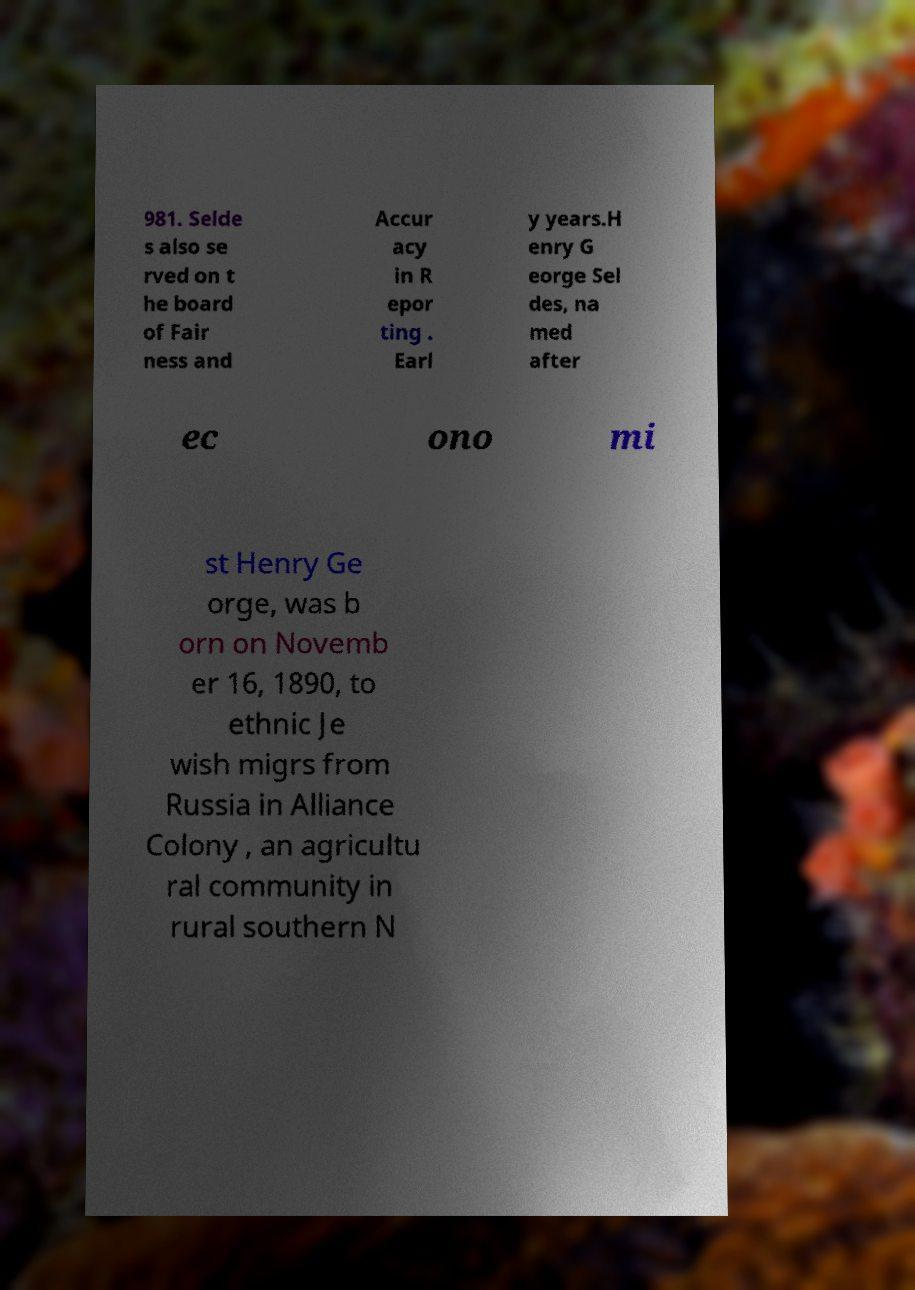For documentation purposes, I need the text within this image transcribed. Could you provide that? 981. Selde s also se rved on t he board of Fair ness and Accur acy in R epor ting . Earl y years.H enry G eorge Sel des, na med after ec ono mi st Henry Ge orge, was b orn on Novemb er 16, 1890, to ethnic Je wish migrs from Russia in Alliance Colony , an agricultu ral community in rural southern N 